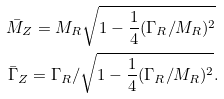<formula> <loc_0><loc_0><loc_500><loc_500>\bar { M } _ { Z } = M _ { R } \sqrt { 1 - \frac { 1 } { 4 } ( \Gamma _ { R } / M _ { R } ) ^ { 2 } } \, \\ \bar { \Gamma } _ { Z } = \Gamma _ { R } / \sqrt { 1 - \frac { 1 } { 4 } ( \Gamma _ { R } / M _ { R } ) ^ { 2 } } .</formula> 